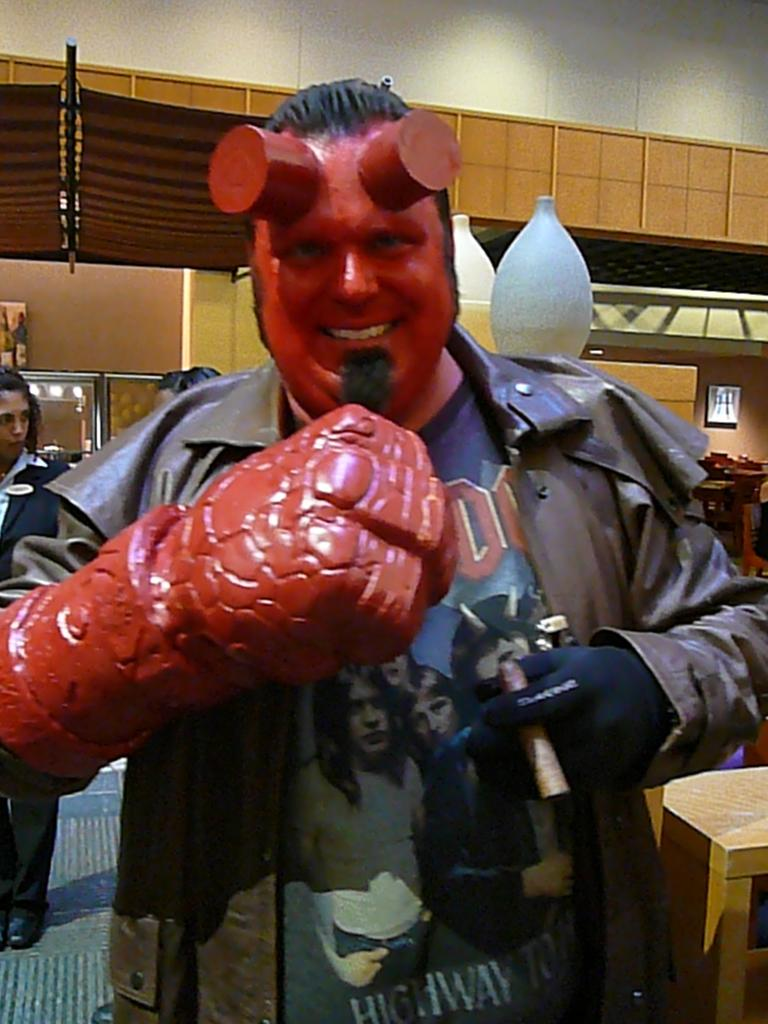Who or what is present in the image? There is a person in the image. What is the person wearing? The person is wearing a red costume. What type of orange is being used to make a connection between the birds in the image? There are no oranges, connections, or birds present in the image. 